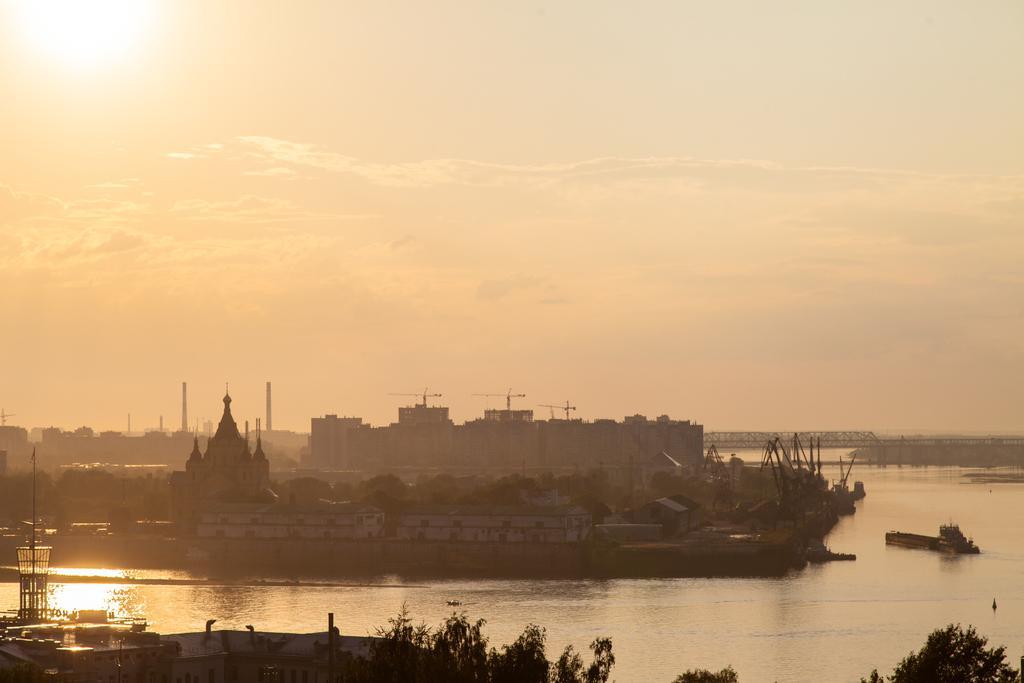How would you summarize this image in a sentence or two? In the center of the image we can see a group of buildings on the land. We can also see some boats in the water. On the bottom of the image we can see some trees. On the backside we can see a bridge and the sky which looks cloudy. 